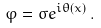<formula> <loc_0><loc_0><loc_500><loc_500>\varphi = \sigma e ^ { i \theta ( x ) } \, .</formula> 